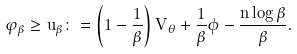Convert formula to latex. <formula><loc_0><loc_0><loc_500><loc_500>\varphi _ { \beta } \geq u _ { \beta } \colon = \left ( 1 - \frac { 1 } { \beta } \right ) V _ { \theta } + \frac { 1 } { \beta } \phi - \frac { n \log \beta } { \beta } .</formula> 